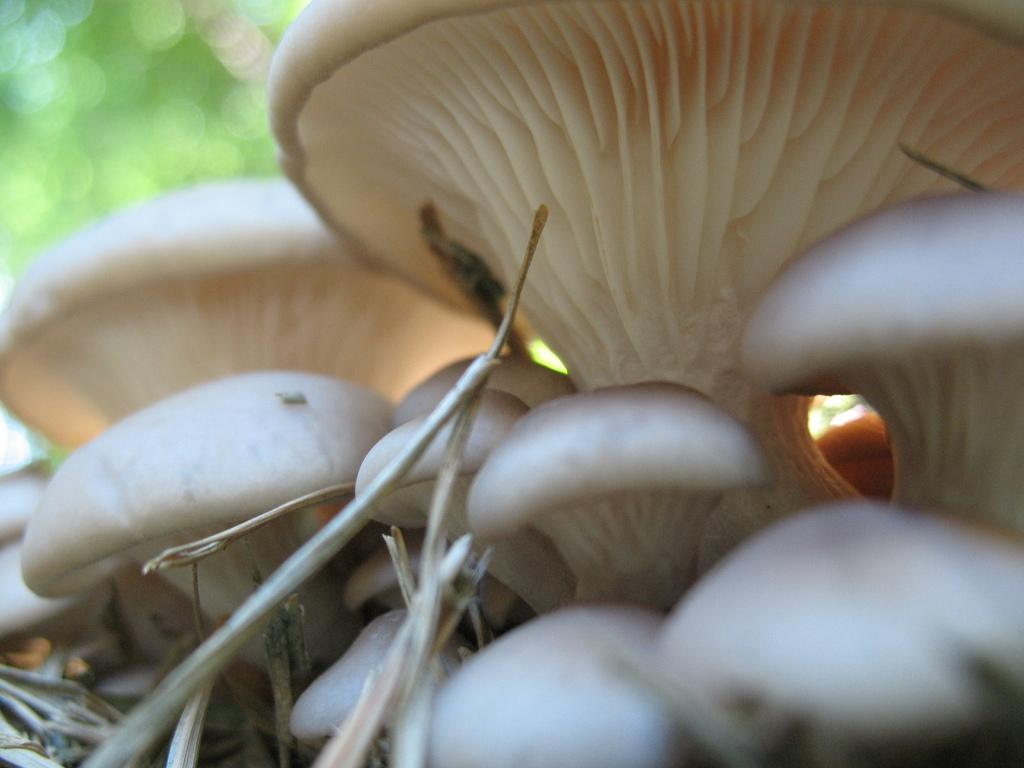What type of fungi can be seen in the image? There are mushrooms in the image. What part of the mushrooms is visible in the image? There are stems in the image. What color is the background of the image? The background color is green. How would you describe the appearance of the background in the image? The background is blurry. What type of key is hanging from the mushroom in the image? There is no key present in the image; it only features mushrooms and a blurry green background. 